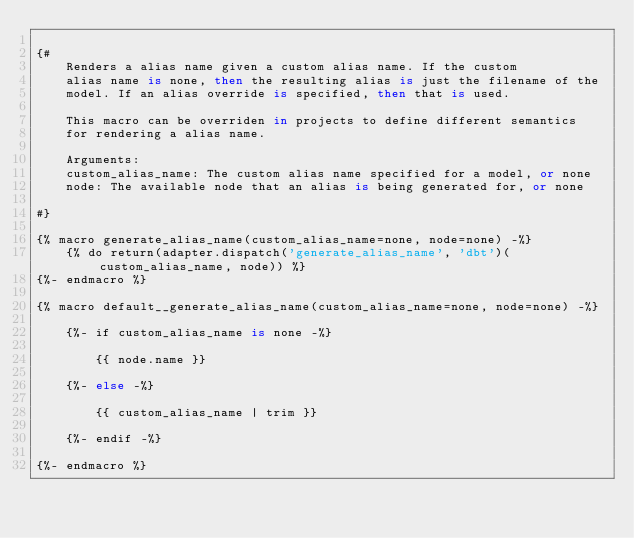Convert code to text. <code><loc_0><loc_0><loc_500><loc_500><_SQL_>
{#
    Renders a alias name given a custom alias name. If the custom
    alias name is none, then the resulting alias is just the filename of the
    model. If an alias override is specified, then that is used.

    This macro can be overriden in projects to define different semantics
    for rendering a alias name.

    Arguments:
    custom_alias_name: The custom alias name specified for a model, or none
    node: The available node that an alias is being generated for, or none

#}

{% macro generate_alias_name(custom_alias_name=none, node=none) -%}
    {% do return(adapter.dispatch('generate_alias_name', 'dbt')(custom_alias_name, node)) %}
{%- endmacro %}

{% macro default__generate_alias_name(custom_alias_name=none, node=none) -%}

    {%- if custom_alias_name is none -%}

        {{ node.name }}

    {%- else -%}

        {{ custom_alias_name | trim }}

    {%- endif -%}

{%- endmacro %}
</code> 